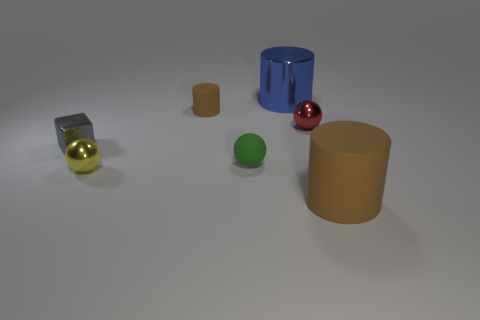Add 2 yellow objects. How many objects exist? 9 Subtract all cylinders. How many objects are left? 4 Subtract 0 purple cylinders. How many objects are left? 7 Subtract all tiny green objects. Subtract all brown matte cylinders. How many objects are left? 4 Add 6 yellow things. How many yellow things are left? 7 Add 5 brown things. How many brown things exist? 7 